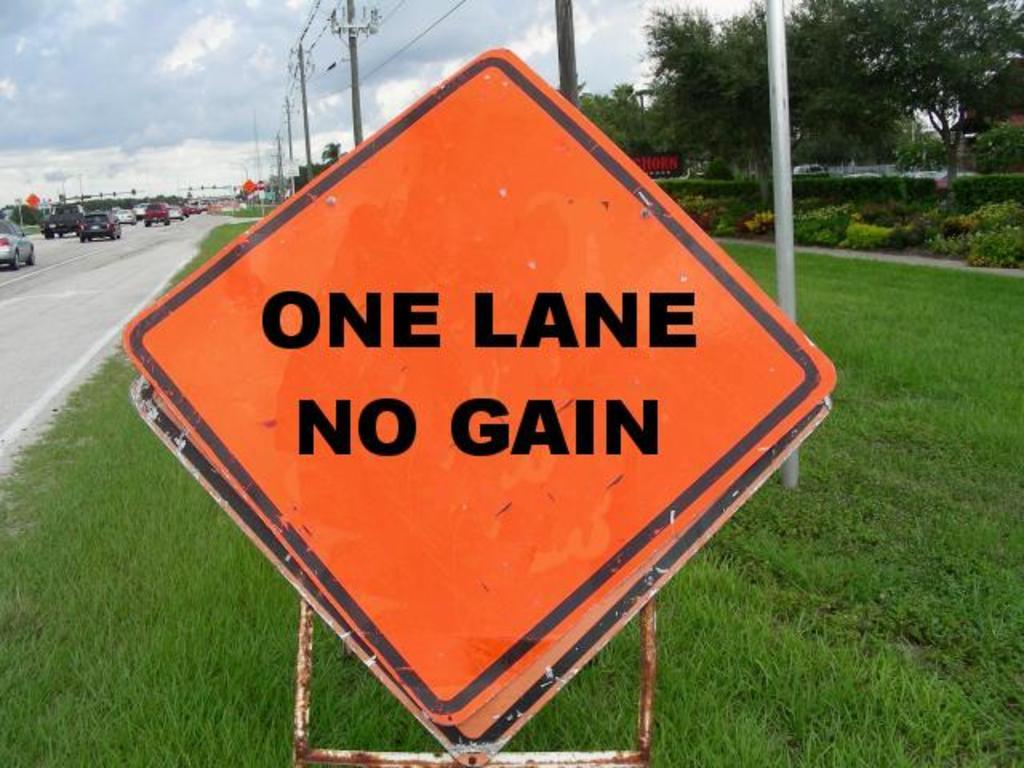<image>
Describe the image concisely. An orange sign on the side of a rode says One Lane No Gain. 